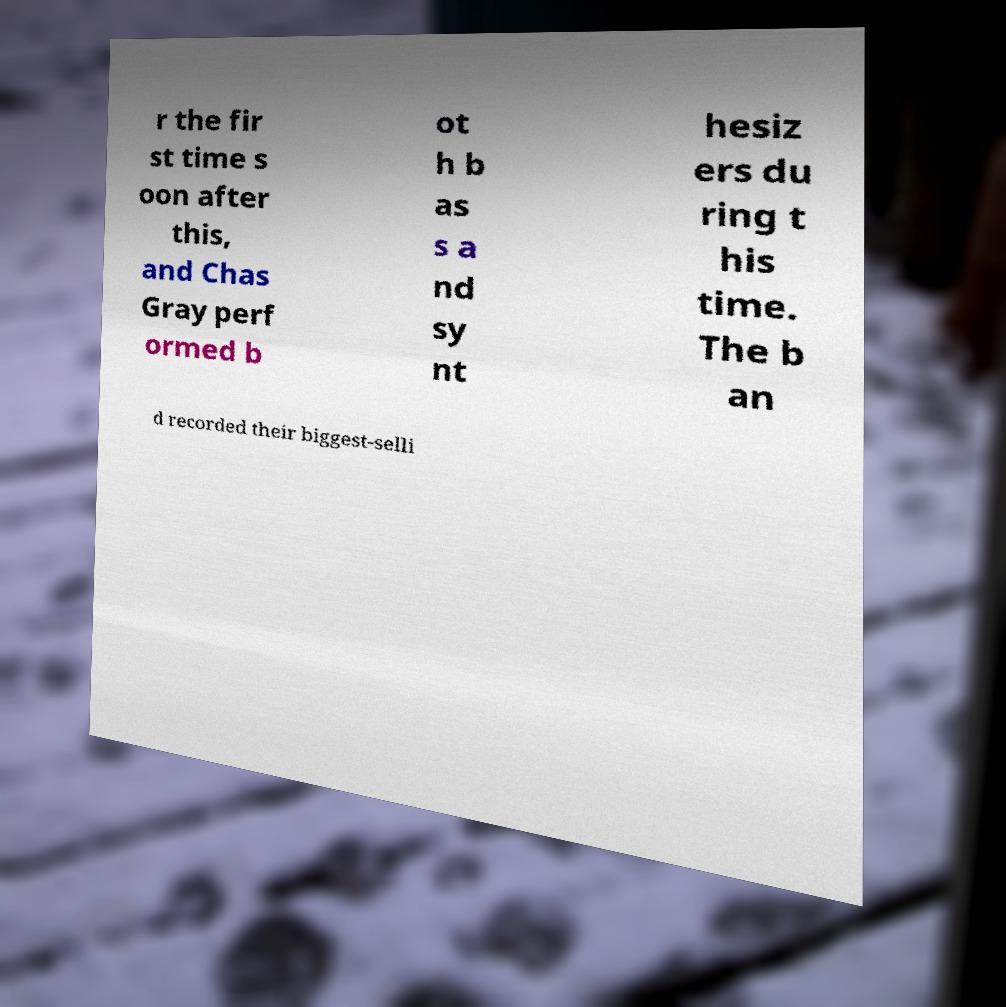Please identify and transcribe the text found in this image. r the fir st time s oon after this, and Chas Gray perf ormed b ot h b as s a nd sy nt hesiz ers du ring t his time. The b an d recorded their biggest-selli 